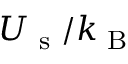<formula> <loc_0><loc_0><loc_500><loc_500>U _ { s } / k _ { B }</formula> 